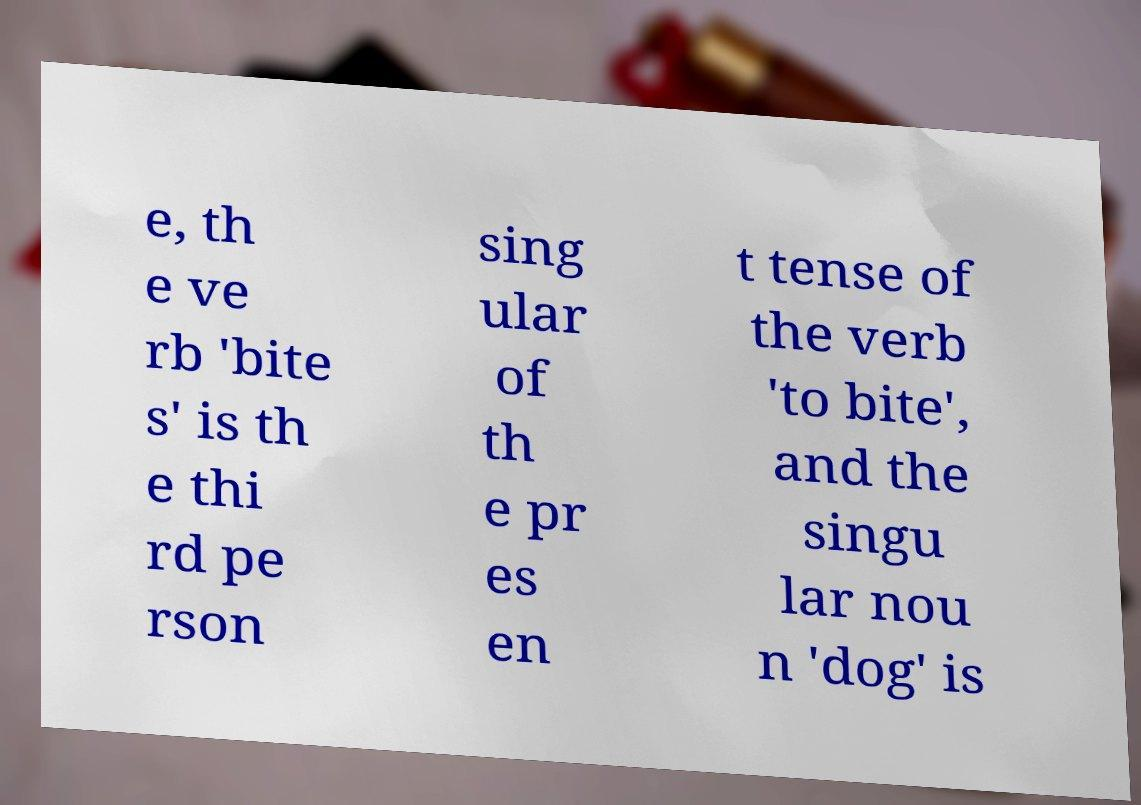Can you accurately transcribe the text from the provided image for me? e, th e ve rb 'bite s' is th e thi rd pe rson sing ular of th e pr es en t tense of the verb 'to bite', and the singu lar nou n 'dog' is 